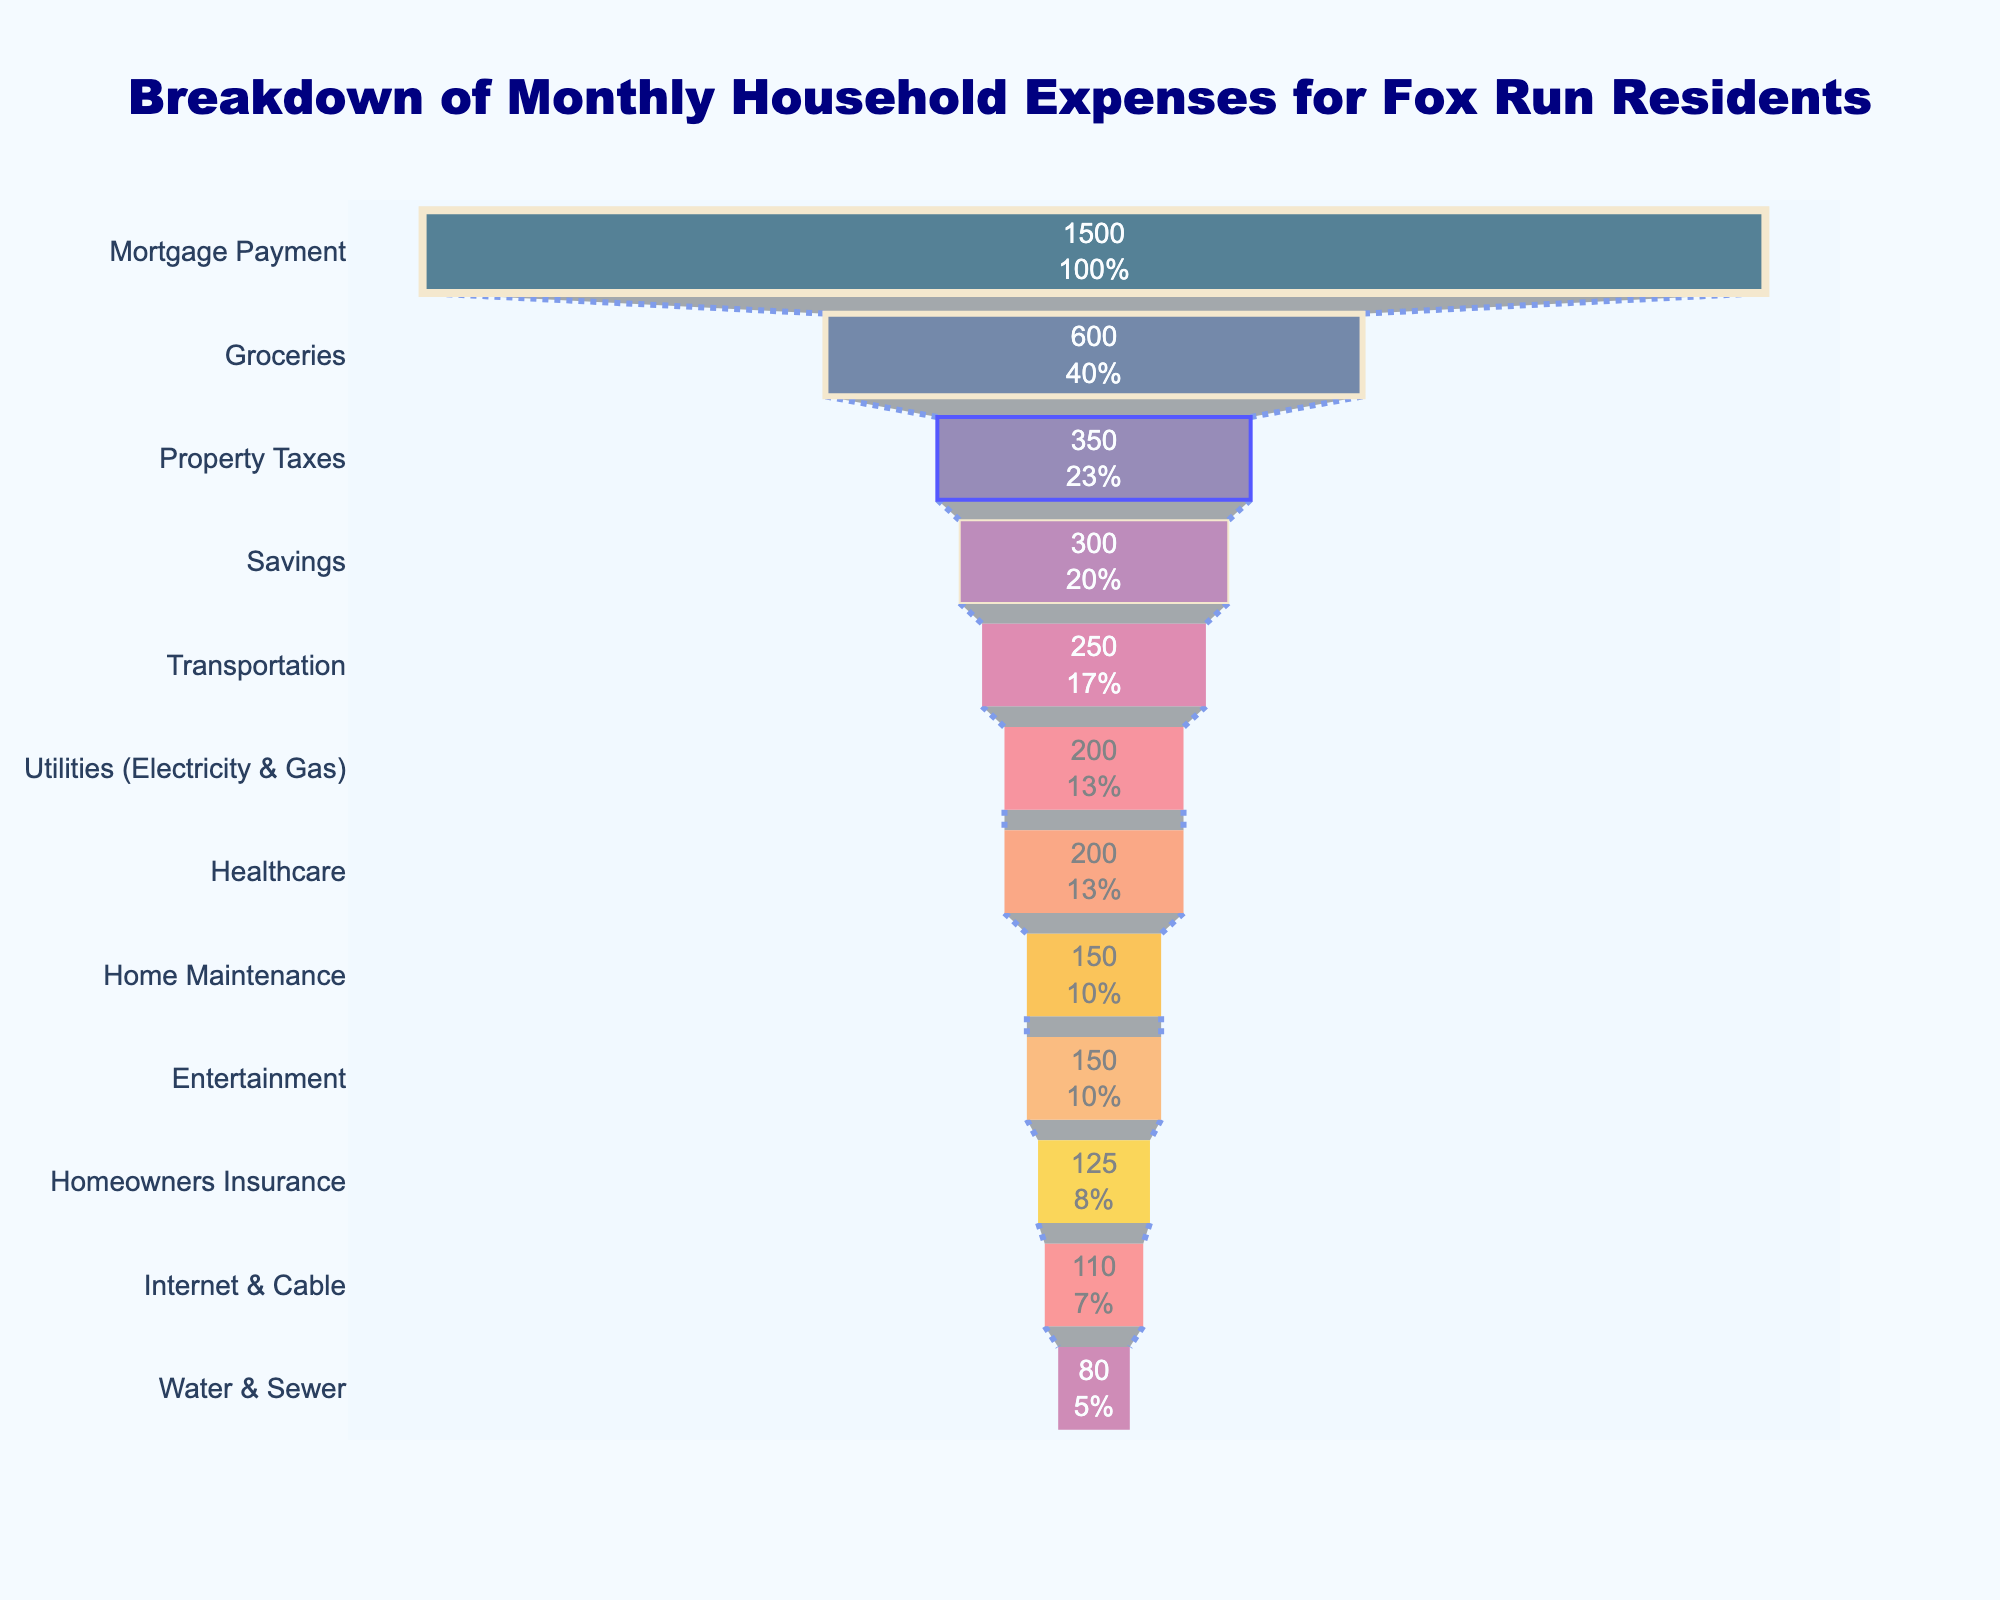What is the largest expense category? The funnel chart starts with the largest expense at the top and goes down to the smallest. The largest category is at the top.
Answer: Mortgage Payment What percentage of the total expenses does Property Taxes take up? Look at the section representing Property Taxes and read the percentage label inside it.
Answer: 11.67% How much do Fox Run residents spend on entertainment compared to healthcare? Locate the expenses for both Entertainment and Healthcare in the funnel chart and compare the values.
Answer: Both are $150 and $200 What is the sum of expenses for Utilities, Transportation, and Healthcare? Identify each category in the funnel chart: Utilities (Electricity & Gas - $200), Transportation ($250), and Healthcare ($200), then sum them up.
Answer: $650 Which category has the least average monthly expense? The funnel chart lists categories from highest to lowest expense; the bottom most category represents the smallest expense.
Answer: Water & Sewer What is the second highest expense category? Find the second bar from the top in the funnel chart to identify the second highest expense category.
Answer: Groceries How much more is spent on Groceries compared to Homeowners Insurance? Find the expense amounts for Groceries ($600) and Homeowners Insurance ($125) and subtract the latter from the former.
Answer: $475 What is the total expense of categories with expenses over $300? Identify and sum the expenses of categories over $300: Mortgage Payment ($1500) and Groceries ($600).
Answer: $2100 Which category is nearest in expense to Internet & Cable? Locate Internet & Cable on the funnel chart and compare adjacent expenses, i.e., those directly above or below.
Answer: Home Maintenance ($150) What overall insight can you draw from the chart about the largest expenses for Fox Run residents? The top three largest expenses are clear to see and can tell us where most of the monthly budget is allocated.
Answer: Mortgage Payment, Groceries, Property Taxes 